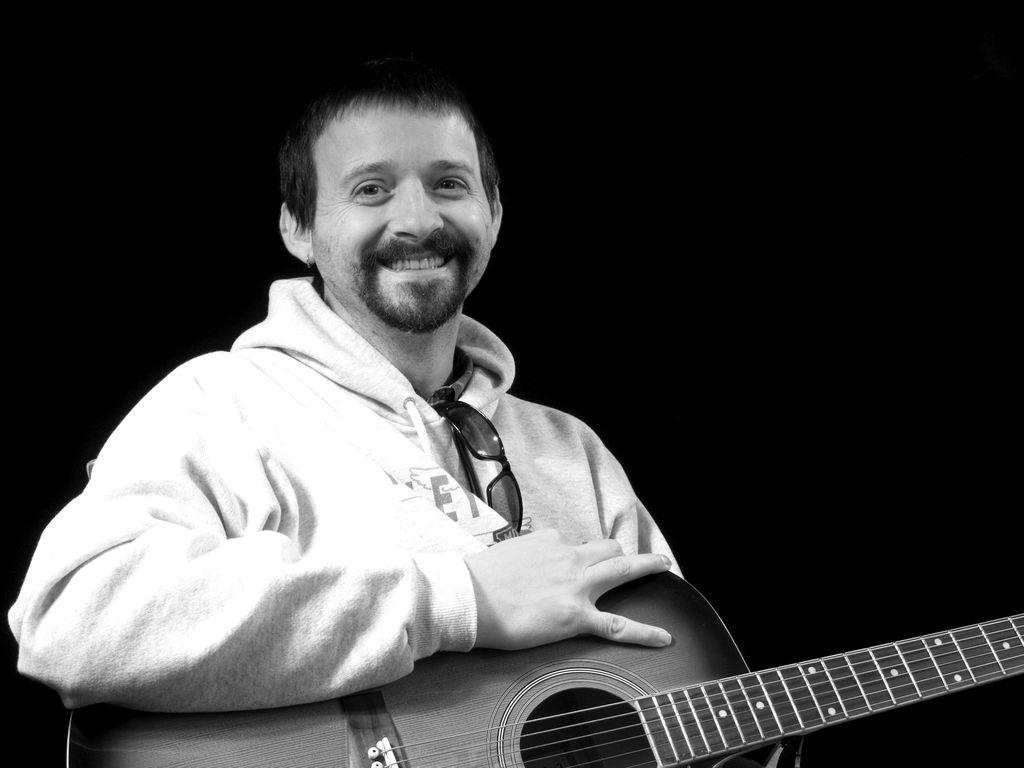What is the main subject of the image? The main subject of the image is a man. What is the man holding in the image? The man is holding a guitar. What type of can is the man using to play the guitar in the image? There is no can present in the image, and the man is not using a can to play the guitar. What type of whip is the man using to play the guitar in the image? There is no whip present in the image, and the man is not using a whip to play the guitar. 